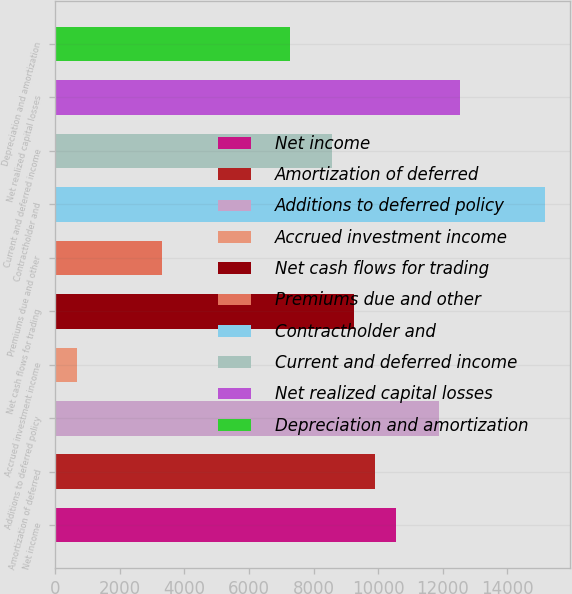Convert chart to OTSL. <chart><loc_0><loc_0><loc_500><loc_500><bar_chart><fcel>Net income<fcel>Amortization of deferred<fcel>Additions to deferred policy<fcel>Accrued investment income<fcel>Net cash flows for trading<fcel>Premiums due and other<fcel>Contractholder and<fcel>Current and deferred income<fcel>Net realized capital losses<fcel>Depreciation and amortization<nl><fcel>10557.1<fcel>9898.55<fcel>11874.2<fcel>678.85<fcel>9240<fcel>3313.05<fcel>15167<fcel>8581.45<fcel>12532.8<fcel>7264.35<nl></chart> 